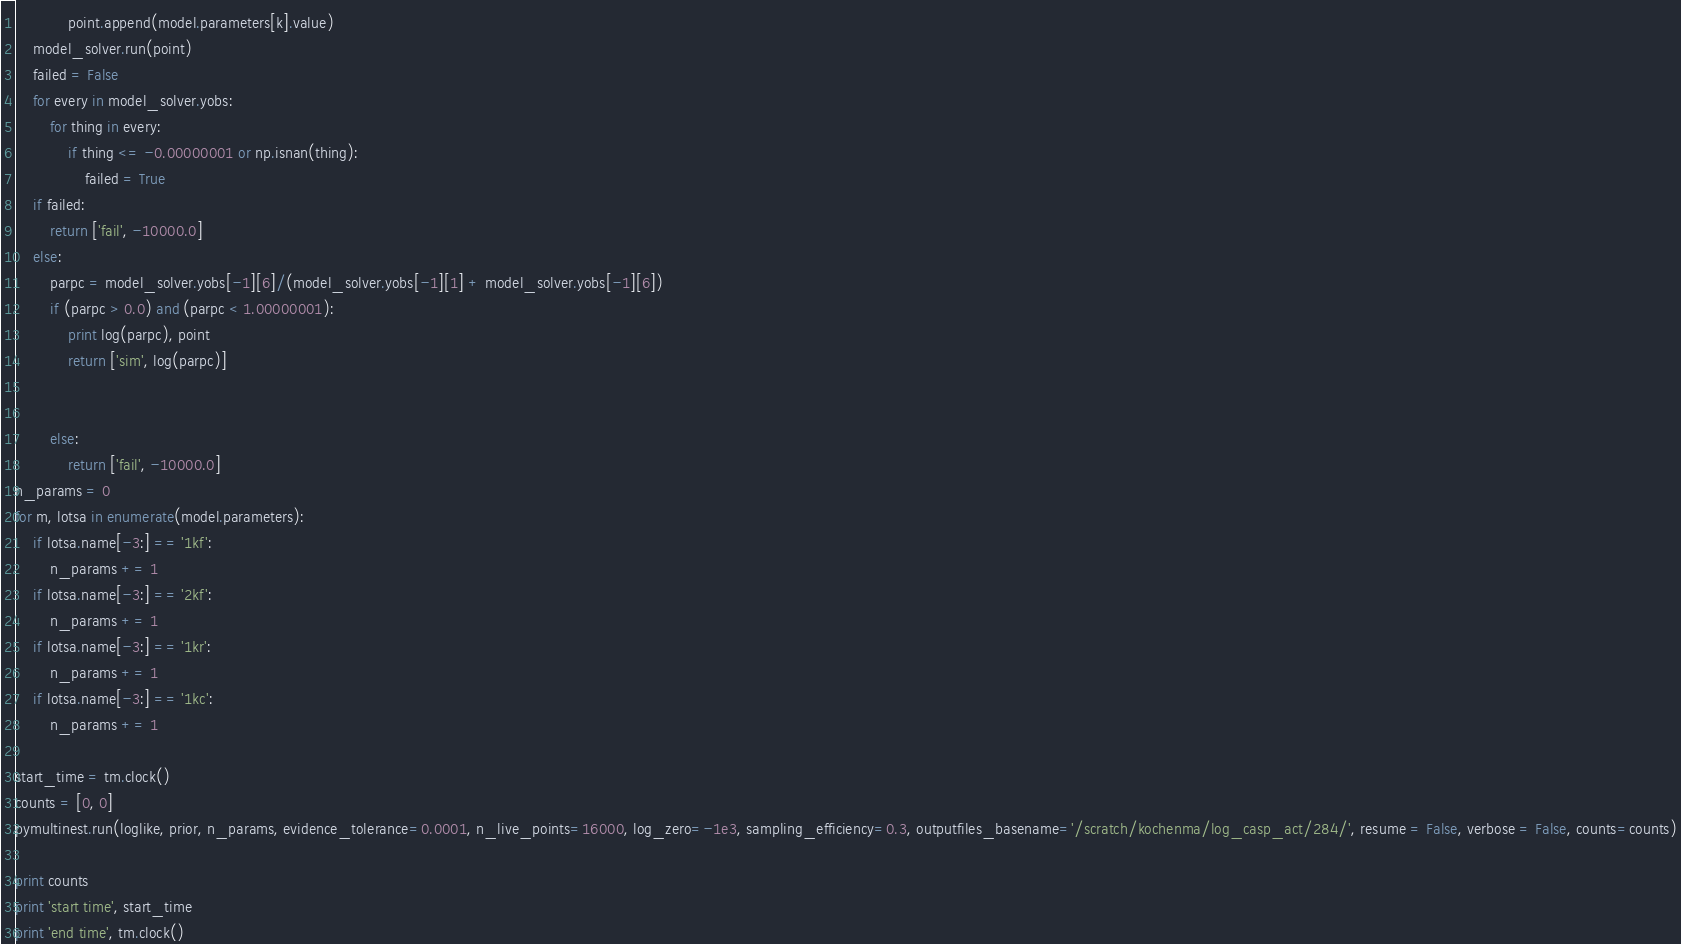Convert code to text. <code><loc_0><loc_0><loc_500><loc_500><_Python_>			point.append(model.parameters[k].value)
	model_solver.run(point)
	failed = False
	for every in model_solver.yobs:
		for thing in every:
			if thing <= -0.00000001 or np.isnan(thing):
				failed = True
	if failed:
		return ['fail', -10000.0]
	else:
		parpc = model_solver.yobs[-1][6]/(model_solver.yobs[-1][1] + model_solver.yobs[-1][6])
		if (parpc > 0.0) and (parpc < 1.00000001):
			print log(parpc), point
			return ['sim', log(parpc)]


		else:
			return ['fail', -10000.0]
n_params = 0
for m, lotsa in enumerate(model.parameters):
	if lotsa.name[-3:] == '1kf':
		n_params += 1
	if lotsa.name[-3:] == '2kf':
		n_params += 1
	if lotsa.name[-3:] == '1kr':
		n_params += 1
	if lotsa.name[-3:] == '1kc':
		n_params += 1

start_time = tm.clock()
counts = [0, 0]
pymultinest.run(loglike, prior, n_params, evidence_tolerance=0.0001, n_live_points=16000, log_zero=-1e3, sampling_efficiency=0.3, outputfiles_basename='/scratch/kochenma/log_casp_act/284/', resume = False, verbose = False, counts=counts)

print counts
print 'start time', start_time
print 'end time', tm.clock()</code> 